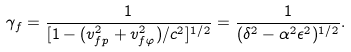<formula> <loc_0><loc_0><loc_500><loc_500>\gamma _ { f } = \frac { 1 } { [ 1 - ( v _ { f p } ^ { 2 } + v _ { f \varphi } ^ { 2 } ) / c ^ { 2 } ] ^ { 1 / 2 } } = \frac { 1 } { ( \delta ^ { 2 } - \alpha ^ { 2 } \epsilon ^ { 2 } ) ^ { 1 / 2 } } .</formula> 